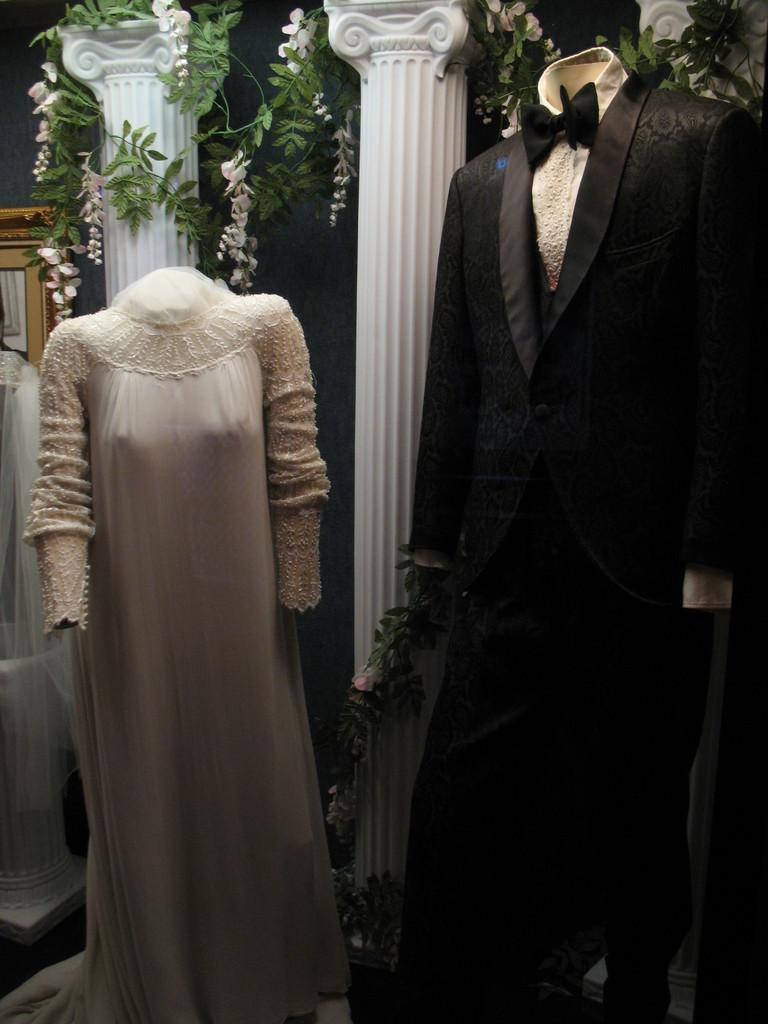In one or two sentences, can you explain what this image depicts? In the foreground of the picture there are mannequins and dresses. At the top there are flowers, leaves and pillars. On the left there are dress and frame. 